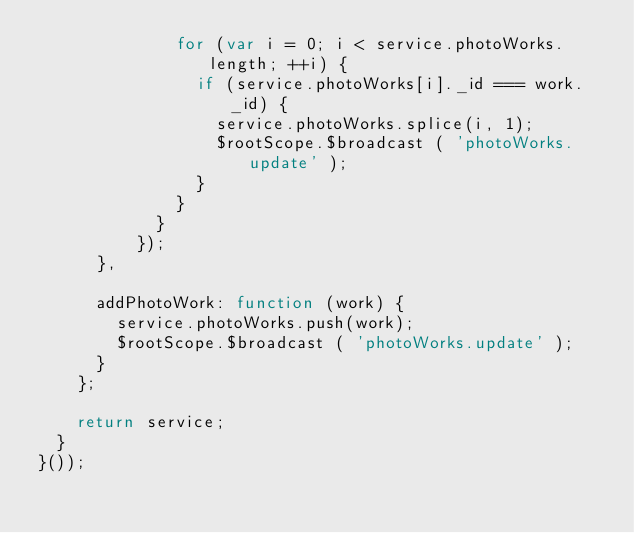<code> <loc_0><loc_0><loc_500><loc_500><_JavaScript_>              for (var i = 0; i < service.photoWorks.length; ++i) {
                if (service.photoWorks[i]._id === work._id) {
                  service.photoWorks.splice(i, 1);
                  $rootScope.$broadcast ( 'photoWorks.update' );
                }
              }
            }
          });
      },

      addPhotoWork: function (work) {
        service.photoWorks.push(work);
        $rootScope.$broadcast ( 'photoWorks.update' );
      }
    };

    return service;
  }
}());
</code> 